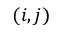Convert formula to latex. <formula><loc_0><loc_0><loc_500><loc_500>( i , j )</formula> 